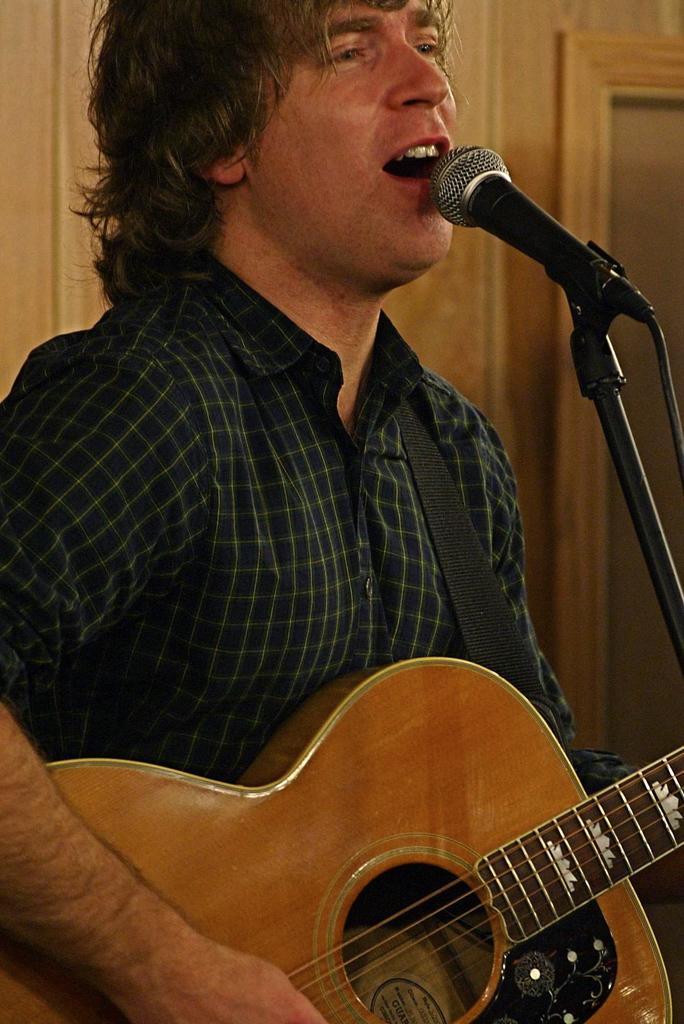Can you describe this image briefly? This is a picture of a man holding a guitar and singing a song in front of the man there is a microphone with stand. Background of the man is a wooden wall. 